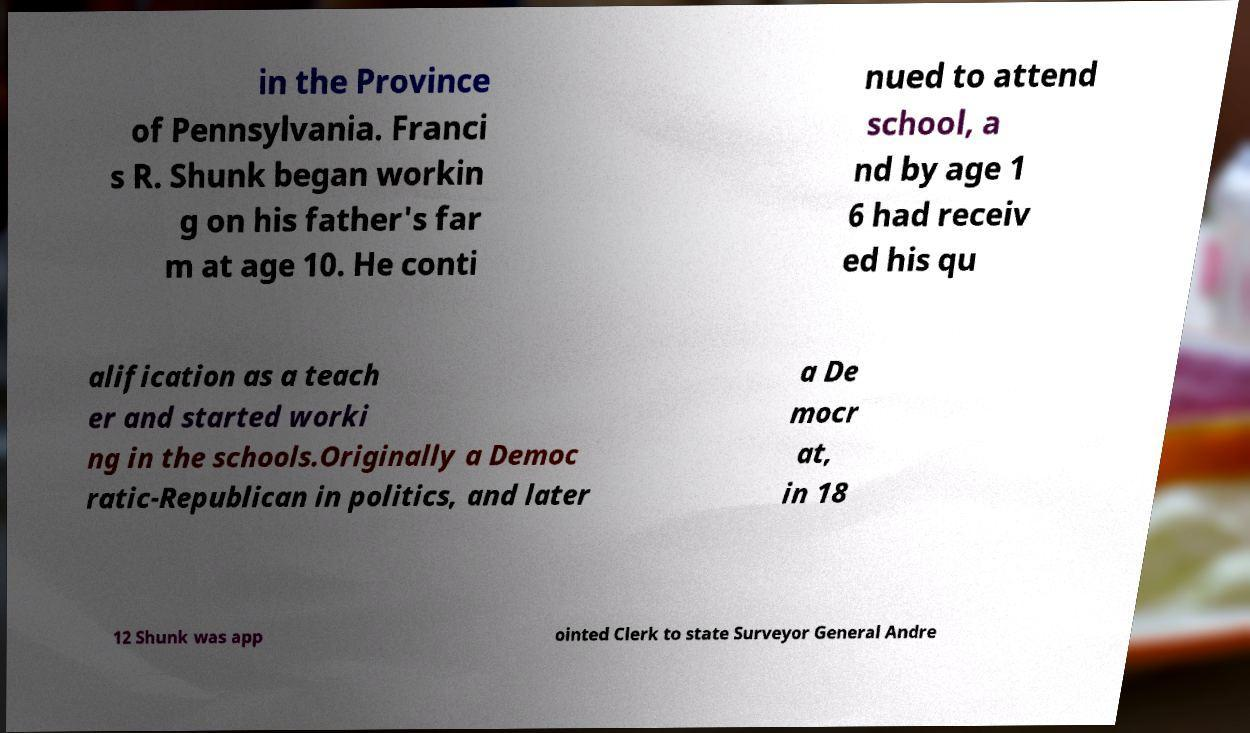There's text embedded in this image that I need extracted. Can you transcribe it verbatim? in the Province of Pennsylvania. Franci s R. Shunk began workin g on his father's far m at age 10. He conti nued to attend school, a nd by age 1 6 had receiv ed his qu alification as a teach er and started worki ng in the schools.Originally a Democ ratic-Republican in politics, and later a De mocr at, in 18 12 Shunk was app ointed Clerk to state Surveyor General Andre 